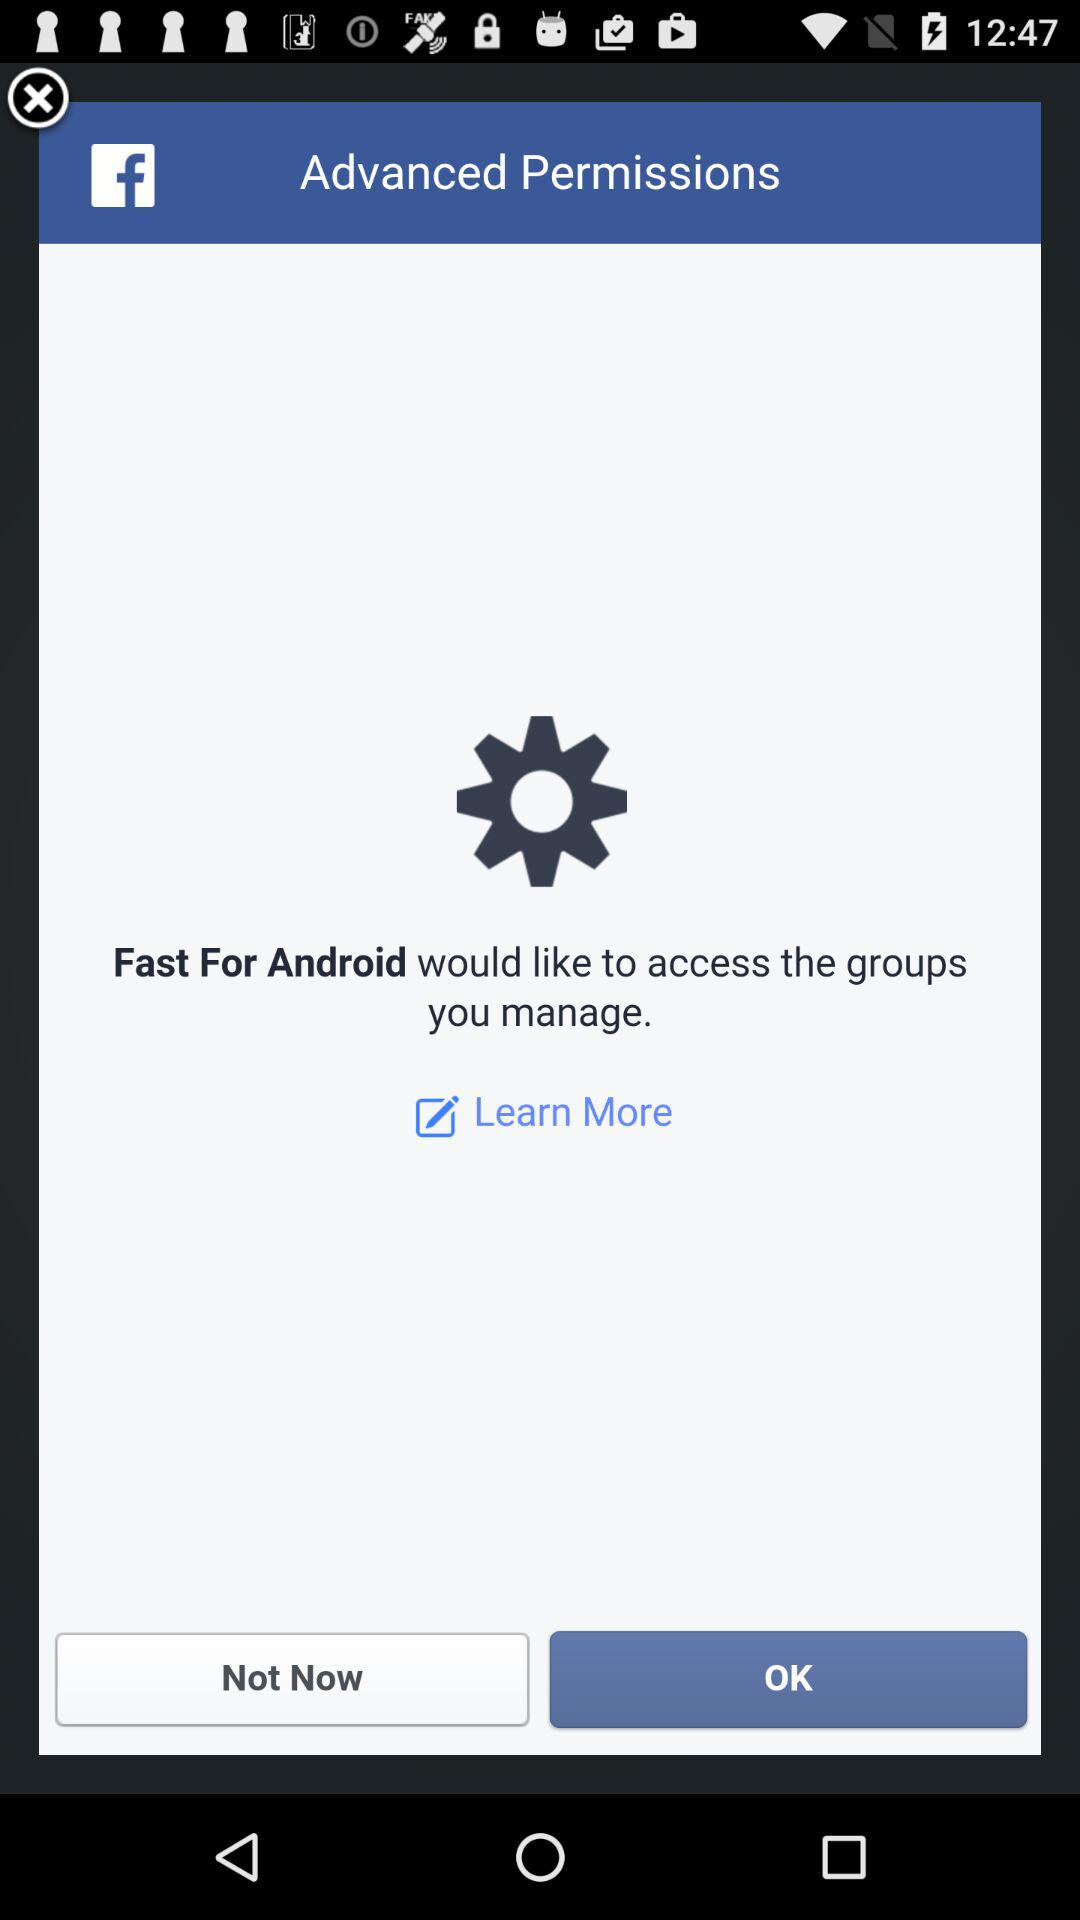What application would like to access the groups that I manage?
Answer the question using a single word or phrase. The application that likes to access the groups that you manage is "Fast For Android." 